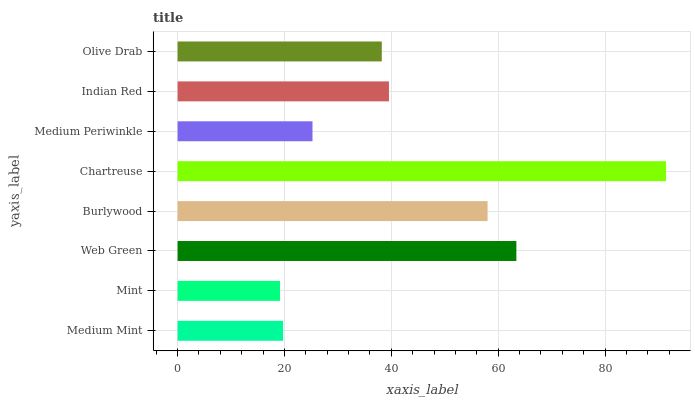Is Mint the minimum?
Answer yes or no. Yes. Is Chartreuse the maximum?
Answer yes or no. Yes. Is Web Green the minimum?
Answer yes or no. No. Is Web Green the maximum?
Answer yes or no. No. Is Web Green greater than Mint?
Answer yes or no. Yes. Is Mint less than Web Green?
Answer yes or no. Yes. Is Mint greater than Web Green?
Answer yes or no. No. Is Web Green less than Mint?
Answer yes or no. No. Is Indian Red the high median?
Answer yes or no. Yes. Is Olive Drab the low median?
Answer yes or no. Yes. Is Burlywood the high median?
Answer yes or no. No. Is Chartreuse the low median?
Answer yes or no. No. 